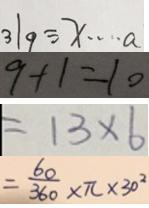Convert formula to latex. <formula><loc_0><loc_0><loc_500><loc_500>3 1 9 \div x \cdots a 
 9 + 1 = 1 0 
 = 1 3 \times 6 
 = \frac { 6 0 } { 3 6 0 } \times \pi \times 3 0 ^ { 2 }</formula> 